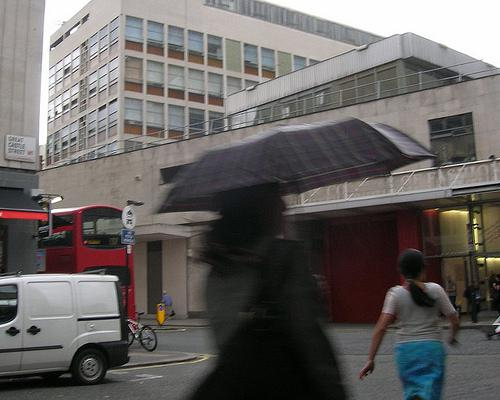Question: who is wearing the blue skirt?
Choices:
A. A man.
B. A boy.
C. A girl.
D. A woman.
Answer with the letter. Answer: D Question: where was this picture taken?
Choices:
A. On the sidewalk.
B. In the yard.
C. On the street.
D. At the beach.
Answer with the letter. Answer: C 